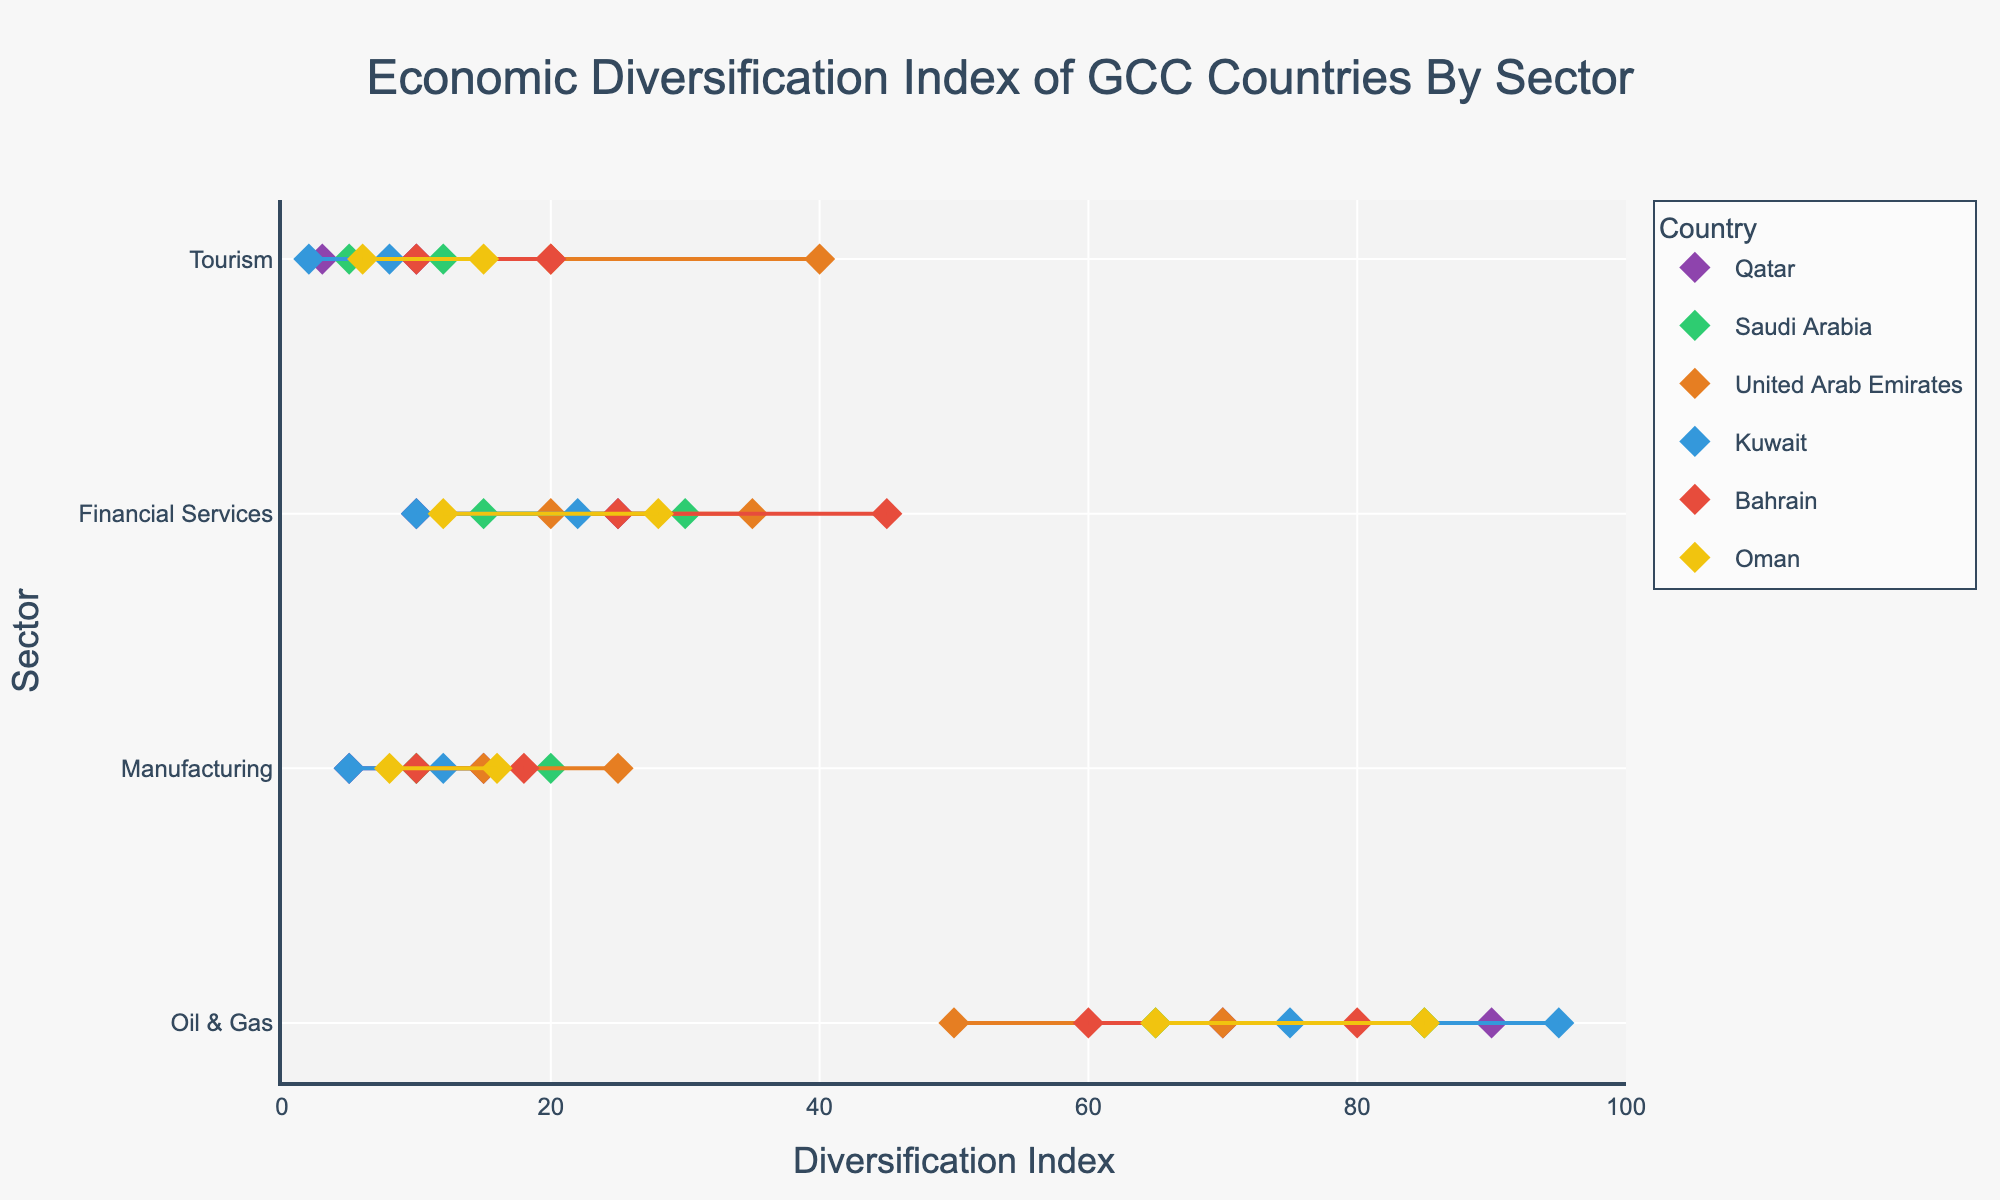What's the title of the figure? The title is displayed prominently at the top of the plot, reading "Economic Diversification Index of GCC Countries By Sector".
Answer: Economic Diversification Index of GCC Countries By Sector Which country has the highest maximum diversification index for the Oil & Gas sector? The plot shows the maximum diversification indices for each country in different sectors. Kuwait's maximum diversification index for the Oil & Gas sector is at 95, which is the highest.
Answer: Kuwait What is the range of the diversification index for the Tourism sector in the United Arab Emirates? The plot shows the minimum and maximum diversification indices for each sector by country. For the United Arab Emirates in the Tourism sector, the minimum is 20 and the maximum is 40.
Answer: 20 to 40 Compare the range of the diversification index for the Financial Services sector between Saudi Arabia and Bahrain. Which country has a broader range? Saudi Arabia’s Financial Services sector has a range from 15 to 30 (which is 15), while Bahrain’s Financial Services sector ranges from 25 to 45 (which is 20). Therefore, Bahrain has a broader range.
Answer: Bahrain In which country and sector is the narrowest range of diversification index observed, and what is the range? By examining the plot, we see that Qatar's Tourism sector has the narrowest range with a minimum diversification index of 3 and a maximum of 10, making the range 7.
Answer: Qatar, Tourism, 3 to 10 What is the approximate midpoint of the diversification index for the Manufacturing sector in Oman? The midpoint can be calculated by averaging the minimum and maximum values. For Oman in the Manufacturing sector, minimum is 8 and maximum is 16. Midpoint is (8 + 16) / 2 = 12.
Answer: 12 Among the presented sectors in the figure, which sector in Qatar has the lowest maximum diversification index and what is the value? Looking at Qatar's sectors' maximum values, the Tourism sector has the lowest maximum diversification index value at 10.
Answer: Tourism, 10 Which sector in Bahrain demonstrates the highest range of diversification index? Calculating the range for Bahraini sectors: Oil & Gas (60-80: 20), Manufacturing (10-18: 8), Financial Services (25-45: 20), and Tourism (10-20: 10). Both Oil & Gas and Financial Services have the highest range of 20.
Answer: Oil & Gas/Financial Services, 20 